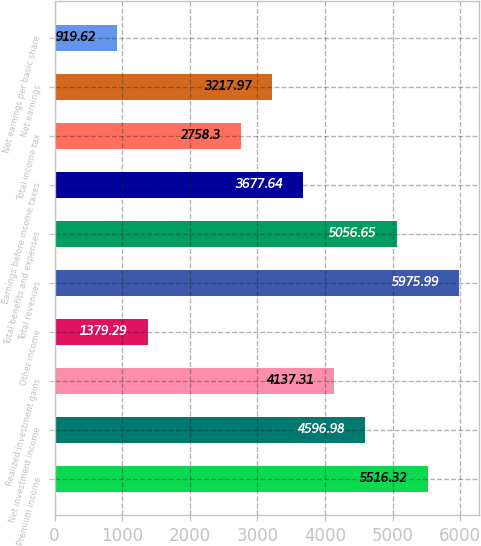<chart> <loc_0><loc_0><loc_500><loc_500><bar_chart><fcel>Premium income<fcel>Net investment income<fcel>Realized investment gains<fcel>Other income<fcel>Total revenues<fcel>Total benefits and expenses<fcel>Earnings before income taxes<fcel>Total income tax<fcel>Net earnings<fcel>Net earnings per basic share<nl><fcel>5516.32<fcel>4596.98<fcel>4137.31<fcel>1379.29<fcel>5975.99<fcel>5056.65<fcel>3677.64<fcel>2758.3<fcel>3217.97<fcel>919.62<nl></chart> 